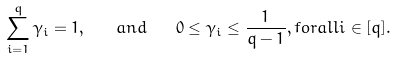Convert formula to latex. <formula><loc_0><loc_0><loc_500><loc_500>\sum _ { i = 1 } ^ { q } \gamma _ { i } = 1 , \quad a n d \quad 0 \leq \gamma _ { i } \leq \frac { 1 } { q - 1 } , f o r a l l i \in [ q ] .</formula> 